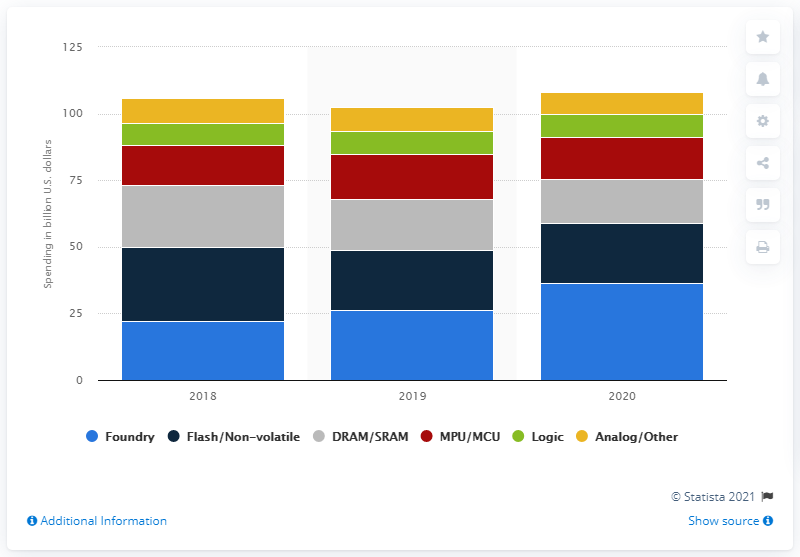Point out several critical features in this image. Foundry capital expenditure was expected to amount to approximately 36.3 in 2020. 